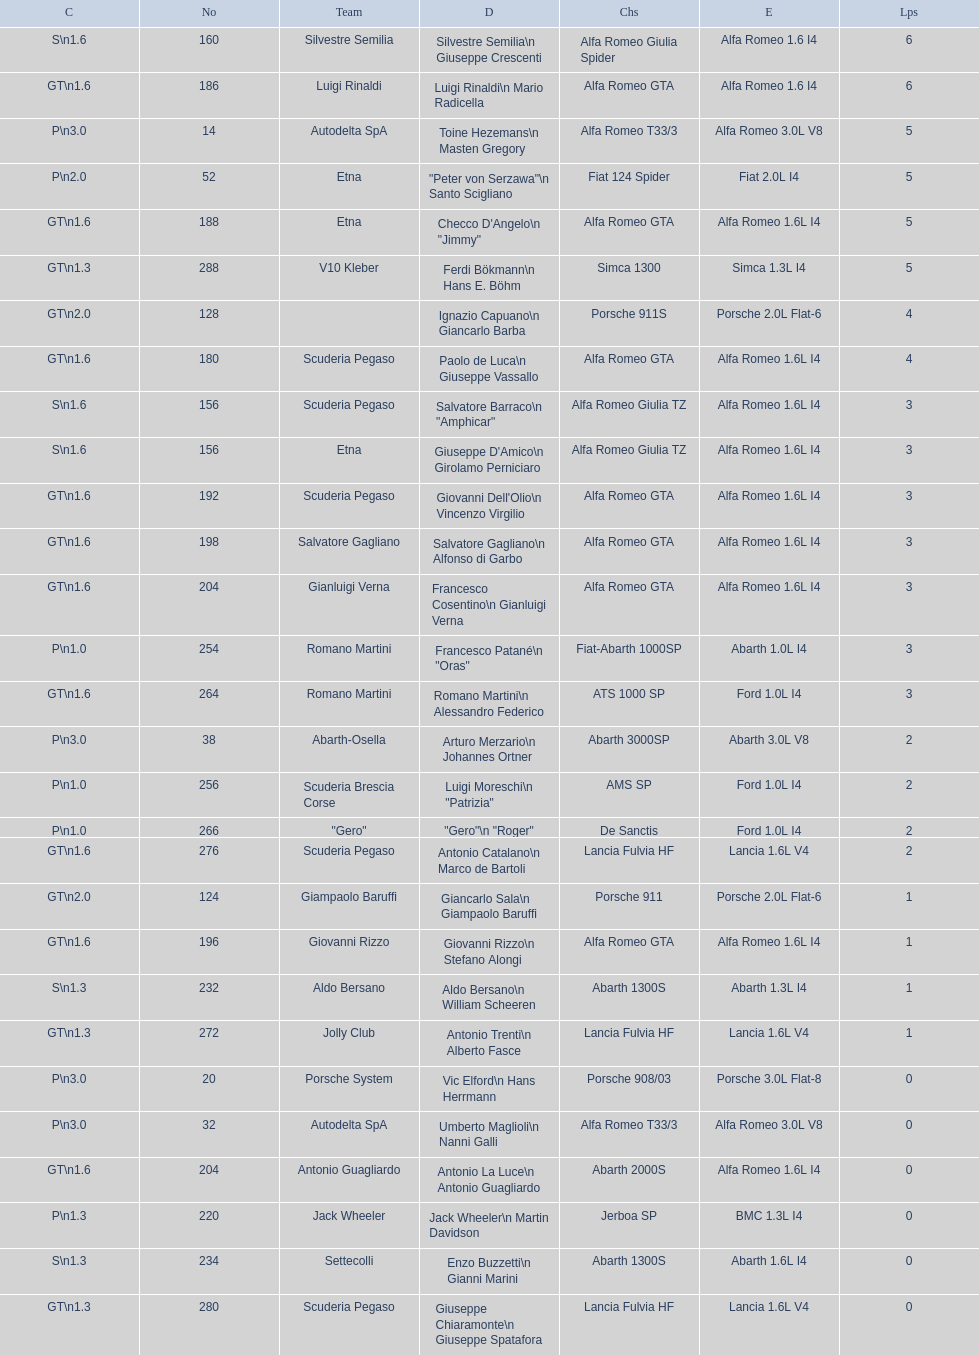What class is below s 1.6? GT 1.6. Would you mind parsing the complete table? {'header': ['C', 'No', 'Team', 'D', 'Chs', 'E', 'Lps'], 'rows': [['S\\n1.6', '160', 'Silvestre Semilia', 'Silvestre Semilia\\n Giuseppe Crescenti', 'Alfa Romeo Giulia Spider', 'Alfa Romeo 1.6 I4', '6'], ['GT\\n1.6', '186', 'Luigi Rinaldi', 'Luigi Rinaldi\\n Mario Radicella', 'Alfa Romeo GTA', 'Alfa Romeo 1.6 I4', '6'], ['P\\n3.0', '14', 'Autodelta SpA', 'Toine Hezemans\\n Masten Gregory', 'Alfa Romeo T33/3', 'Alfa Romeo 3.0L V8', '5'], ['P\\n2.0', '52', 'Etna', '"Peter von Serzawa"\\n Santo Scigliano', 'Fiat 124 Spider', 'Fiat 2.0L I4', '5'], ['GT\\n1.6', '188', 'Etna', 'Checco D\'Angelo\\n "Jimmy"', 'Alfa Romeo GTA', 'Alfa Romeo 1.6L I4', '5'], ['GT\\n1.3', '288', 'V10 Kleber', 'Ferdi Bökmann\\n Hans E. Böhm', 'Simca 1300', 'Simca 1.3L I4', '5'], ['GT\\n2.0', '128', '', 'Ignazio Capuano\\n Giancarlo Barba', 'Porsche 911S', 'Porsche 2.0L Flat-6', '4'], ['GT\\n1.6', '180', 'Scuderia Pegaso', 'Paolo de Luca\\n Giuseppe Vassallo', 'Alfa Romeo GTA', 'Alfa Romeo 1.6L I4', '4'], ['S\\n1.6', '156', 'Scuderia Pegaso', 'Salvatore Barraco\\n "Amphicar"', 'Alfa Romeo Giulia TZ', 'Alfa Romeo 1.6L I4', '3'], ['S\\n1.6', '156', 'Etna', "Giuseppe D'Amico\\n Girolamo Perniciaro", 'Alfa Romeo Giulia TZ', 'Alfa Romeo 1.6L I4', '3'], ['GT\\n1.6', '192', 'Scuderia Pegaso', "Giovanni Dell'Olio\\n Vincenzo Virgilio", 'Alfa Romeo GTA', 'Alfa Romeo 1.6L I4', '3'], ['GT\\n1.6', '198', 'Salvatore Gagliano', 'Salvatore Gagliano\\n Alfonso di Garbo', 'Alfa Romeo GTA', 'Alfa Romeo 1.6L I4', '3'], ['GT\\n1.6', '204', 'Gianluigi Verna', 'Francesco Cosentino\\n Gianluigi Verna', 'Alfa Romeo GTA', 'Alfa Romeo 1.6L I4', '3'], ['P\\n1.0', '254', 'Romano Martini', 'Francesco Patané\\n "Oras"', 'Fiat-Abarth 1000SP', 'Abarth 1.0L I4', '3'], ['GT\\n1.6', '264', 'Romano Martini', 'Romano Martini\\n Alessandro Federico', 'ATS 1000 SP', 'Ford 1.0L I4', '3'], ['P\\n3.0', '38', 'Abarth-Osella', 'Arturo Merzario\\n Johannes Ortner', 'Abarth 3000SP', 'Abarth 3.0L V8', '2'], ['P\\n1.0', '256', 'Scuderia Brescia Corse', 'Luigi Moreschi\\n "Patrizia"', 'AMS SP', 'Ford 1.0L I4', '2'], ['P\\n1.0', '266', '"Gero"', '"Gero"\\n "Roger"', 'De Sanctis', 'Ford 1.0L I4', '2'], ['GT\\n1.6', '276', 'Scuderia Pegaso', 'Antonio Catalano\\n Marco de Bartoli', 'Lancia Fulvia HF', 'Lancia 1.6L V4', '2'], ['GT\\n2.0', '124', 'Giampaolo Baruffi', 'Giancarlo Sala\\n Giampaolo Baruffi', 'Porsche 911', 'Porsche 2.0L Flat-6', '1'], ['GT\\n1.6', '196', 'Giovanni Rizzo', 'Giovanni Rizzo\\n Stefano Alongi', 'Alfa Romeo GTA', 'Alfa Romeo 1.6L I4', '1'], ['S\\n1.3', '232', 'Aldo Bersano', 'Aldo Bersano\\n William Scheeren', 'Abarth 1300S', 'Abarth 1.3L I4', '1'], ['GT\\n1.3', '272', 'Jolly Club', 'Antonio Trenti\\n Alberto Fasce', 'Lancia Fulvia HF', 'Lancia 1.6L V4', '1'], ['P\\n3.0', '20', 'Porsche System', 'Vic Elford\\n Hans Herrmann', 'Porsche 908/03', 'Porsche 3.0L Flat-8', '0'], ['P\\n3.0', '32', 'Autodelta SpA', 'Umberto Maglioli\\n Nanni Galli', 'Alfa Romeo T33/3', 'Alfa Romeo 3.0L V8', '0'], ['GT\\n1.6', '204', 'Antonio Guagliardo', 'Antonio La Luce\\n Antonio Guagliardo', 'Abarth 2000S', 'Alfa Romeo 1.6L I4', '0'], ['P\\n1.3', '220', 'Jack Wheeler', 'Jack Wheeler\\n Martin Davidson', 'Jerboa SP', 'BMC 1.3L I4', '0'], ['S\\n1.3', '234', 'Settecolli', 'Enzo Buzzetti\\n Gianni Marini', 'Abarth 1300S', 'Abarth 1.6L I4', '0'], ['GT\\n1.3', '280', 'Scuderia Pegaso', 'Giuseppe Chiaramonte\\n Giuseppe Spatafora', 'Lancia Fulvia HF', 'Lancia 1.6L V4', '0']]} 